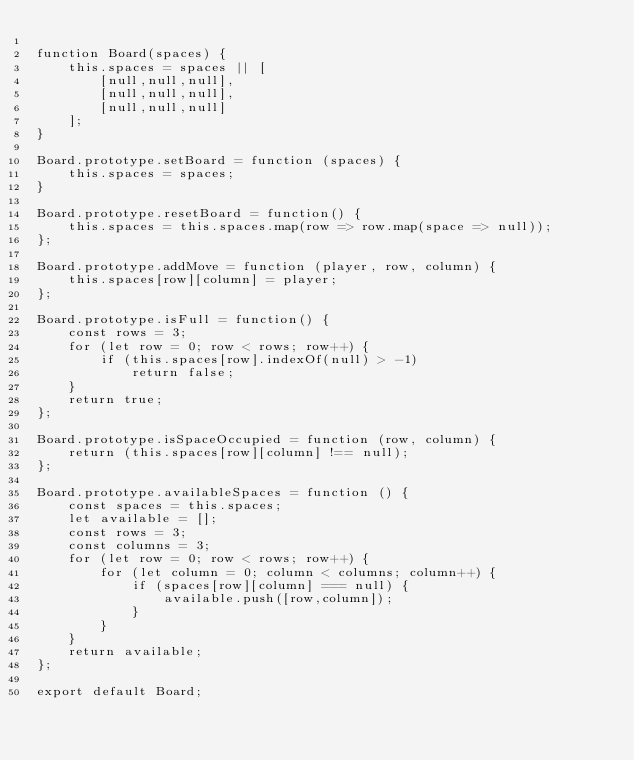Convert code to text. <code><loc_0><loc_0><loc_500><loc_500><_JavaScript_>
function Board(spaces) {
    this.spaces = spaces || [
        [null,null,null],
        [null,null,null],
        [null,null,null]
    ];
}

Board.prototype.setBoard = function (spaces) {
    this.spaces = spaces;
}

Board.prototype.resetBoard = function() {
    this.spaces = this.spaces.map(row => row.map(space => null));
};

Board.prototype.addMove = function (player, row, column) {
    this.spaces[row][column] = player;
};

Board.prototype.isFull = function() {
    const rows = 3;
    for (let row = 0; row < rows; row++) {
        if (this.spaces[row].indexOf(null) > -1)
            return false;
    }
    return true;
};

Board.prototype.isSpaceOccupied = function (row, column) {
    return (this.spaces[row][column] !== null);
};

Board.prototype.availableSpaces = function () {
    const spaces = this.spaces;
    let available = [];
    const rows = 3;
    const columns = 3;
    for (let row = 0; row < rows; row++) {
        for (let column = 0; column < columns; column++) {
            if (spaces[row][column] === null) {
                available.push([row,column]);
            }
        }
    }
    return available;
};

export default Board;
</code> 